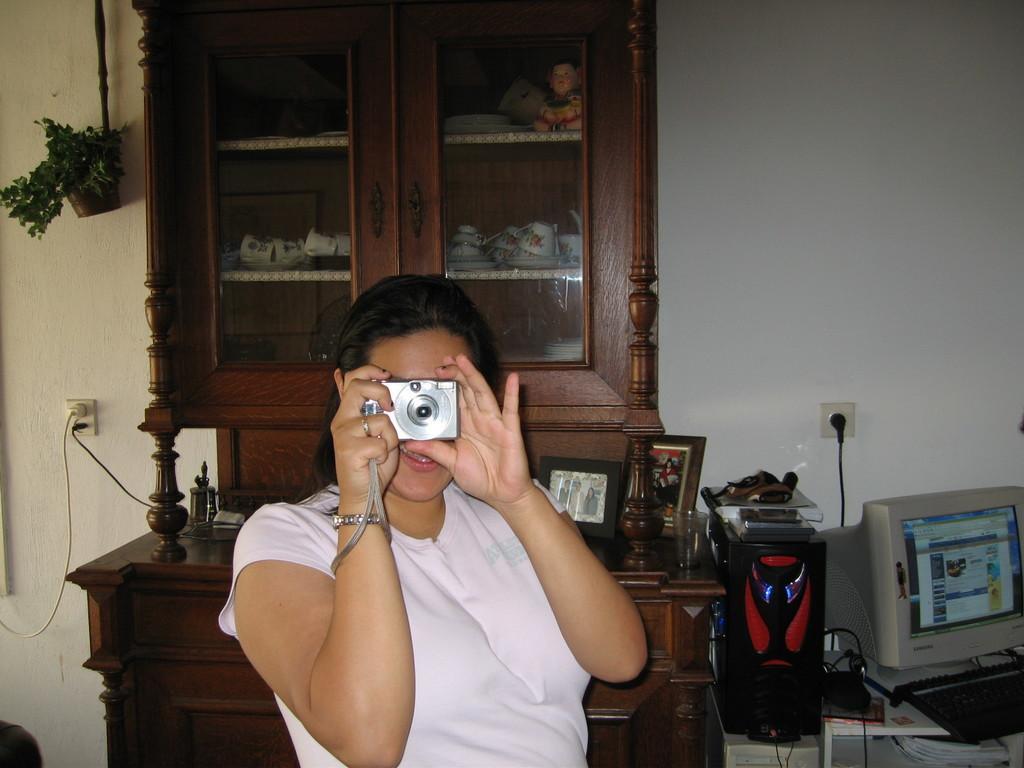Describe this image in one or two sentences. Here we can see a woman is sitting, and holding a camera in her hands, and at back here is the computer, and here are some objects on the table, and here is the wall. 